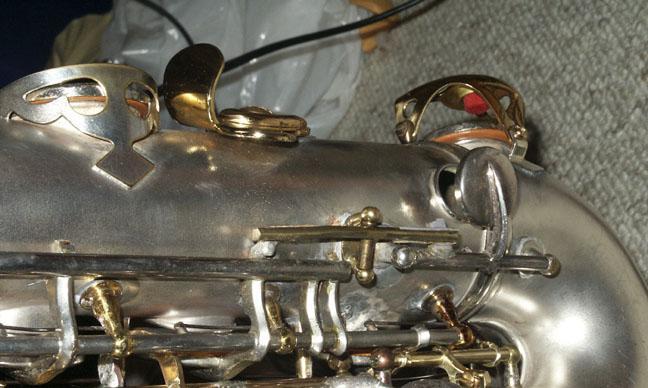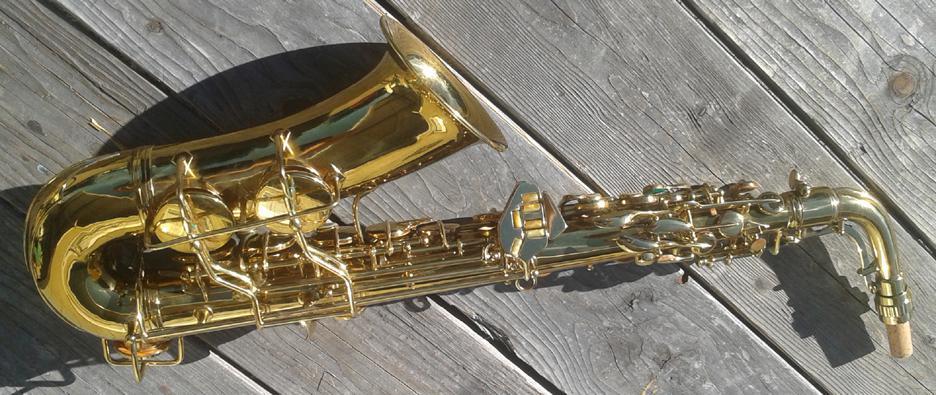The first image is the image on the left, the second image is the image on the right. Considering the images on both sides, is "One image shows the etched bell of a gold saxophone, which is displayed on burgundy fabric." valid? Answer yes or no. No. The first image is the image on the left, the second image is the image on the right. Examine the images to the left and right. Is the description "The saxophone in the image on the right is sitting in a case with a red lining." accurate? Answer yes or no. No. 